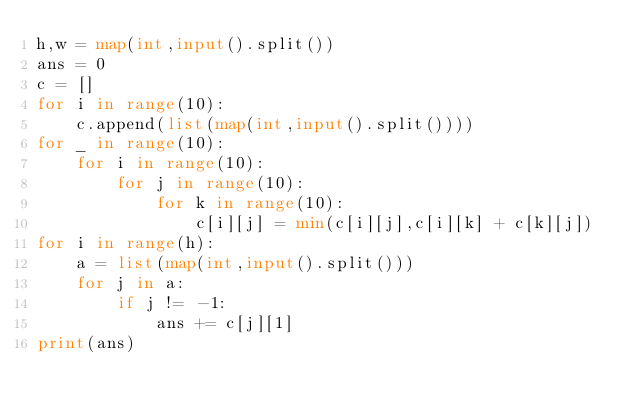Convert code to text. <code><loc_0><loc_0><loc_500><loc_500><_Python_>h,w = map(int,input().split())
ans = 0
c = []
for i in range(10):
    c.append(list(map(int,input().split())))
for _ in range(10):
    for i in range(10):
        for j in range(10):
            for k in range(10):
                c[i][j] = min(c[i][j],c[i][k] + c[k][j])
for i in range(h):
    a = list(map(int,input().split()))
    for j in a:
        if j != -1:
            ans += c[j][1]
print(ans)</code> 